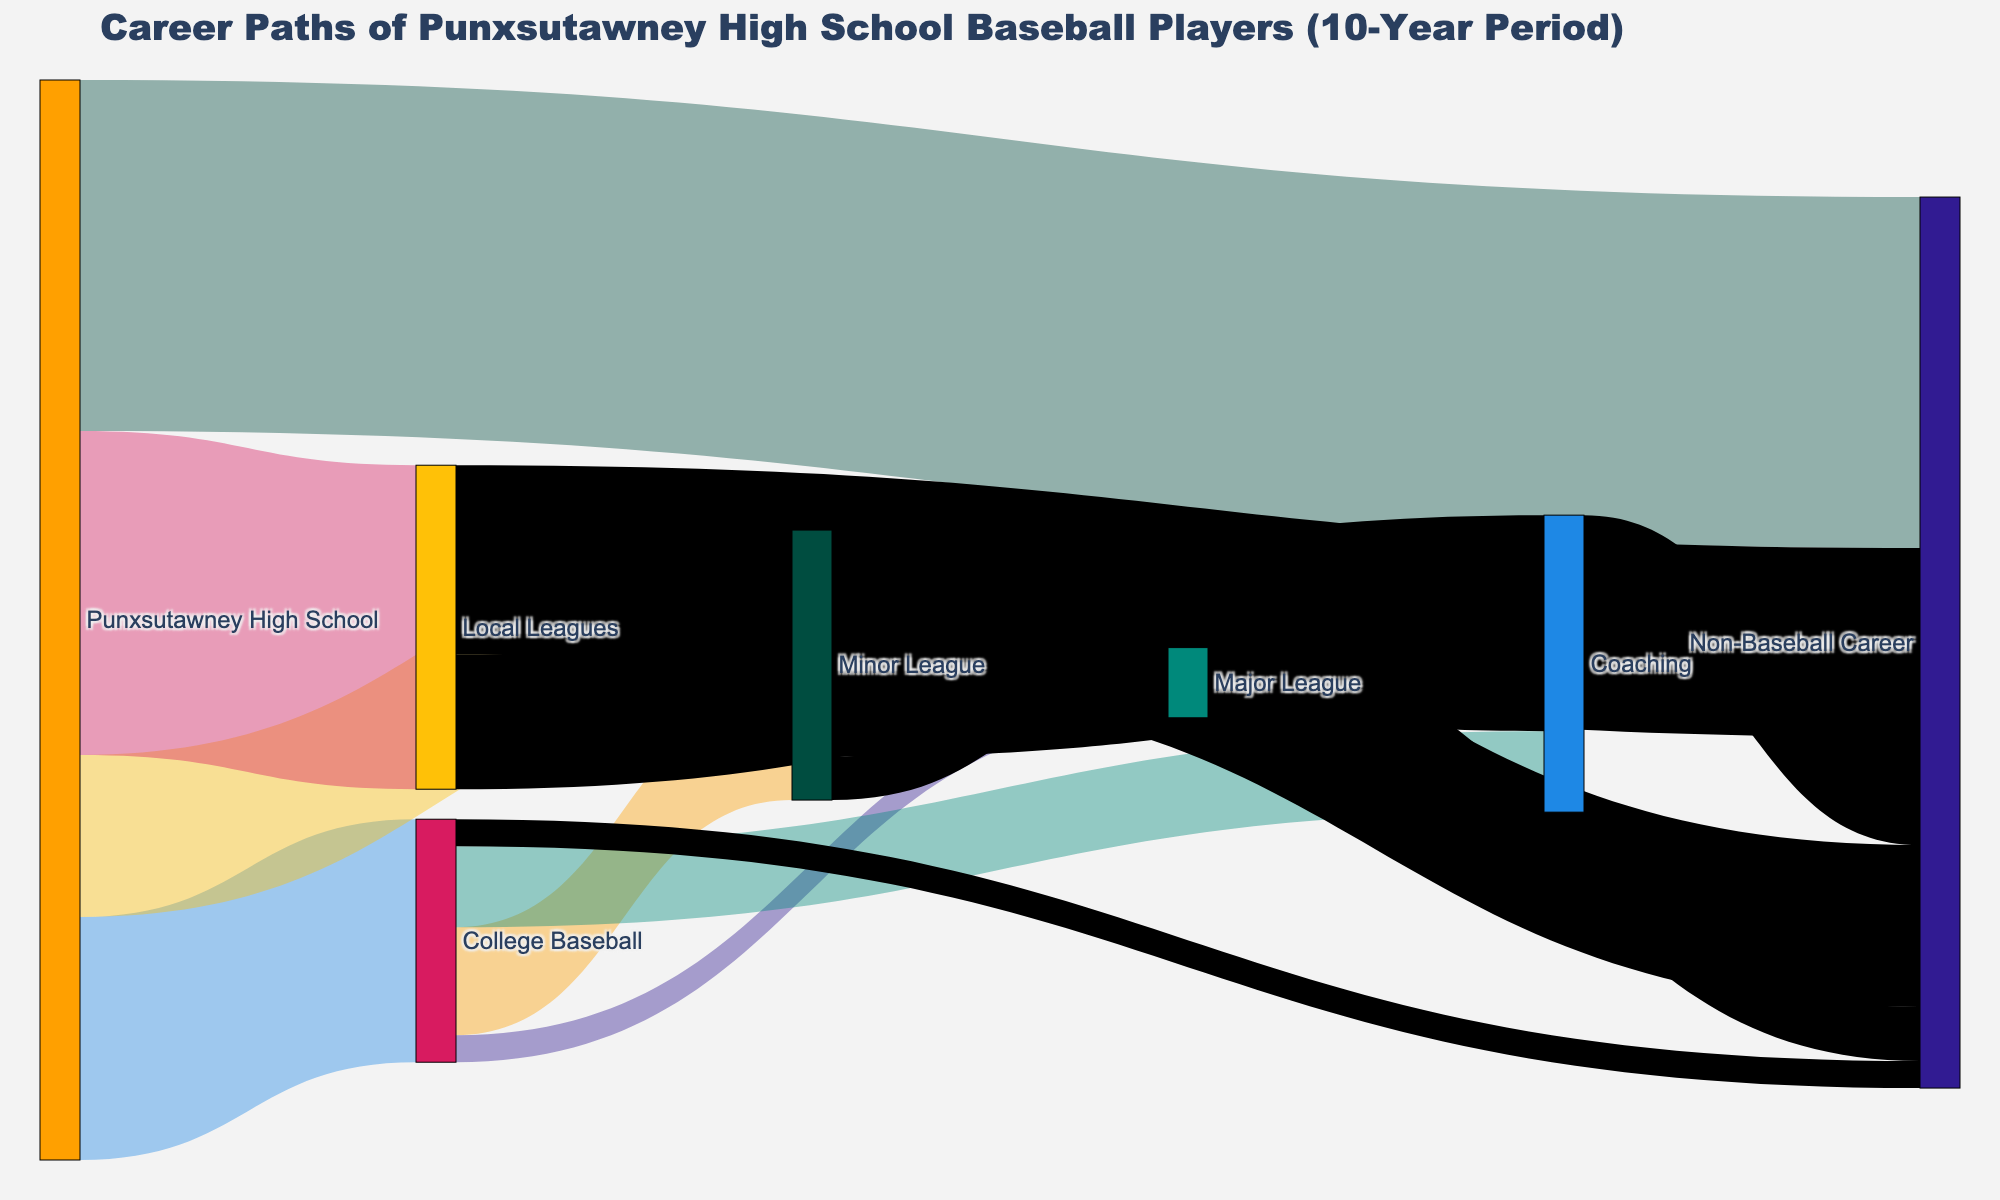What is the title of the figure? The title of the Sankey Diagram is usually located at the top of the figure. By reading this title, one can understand the primary focus of the figure.
Answer: Career Paths of Punxsutawney High School Baseball Players (10-Year Period) How many players went directly from Punxsutawney High School to College Baseball? By looking at the width of the stream and the label between "Punxsutawney High School" and "College Baseball," one can see the number of players.
Answer: 45 What is the total number of players who pursued a career in Coaching? To determine the total number of Coaches, sum the values of streams ending at "Coaching." They come from College Baseball (15), Minor League (12), Local Leagues (25), and Major Leagues (3): 15+12+25+3=55.
Answer: 55 Which career path has the highest number of players starting from Punxsutawney High School? To find this, identify which stream originating from "Punxsutawney High School" is the widest and has the largest value.
Answer: Non-Baseball Career How many players transitioned from College Baseball to a major league career? Look at the width of the stream between "College Baseball" and "Major League" and refer to the label for the exact number.
Answer: 5 What percentage of players from Punxsutawney High School joined Local Leagues? The total number of students from Punxsutawney High School is 200 (sum of all outgoing streams). Calculate the percentage: (60/200) * 100 = 30%.
Answer: 30% Compare the number of players in the Minor League to those in the Major League. Combine the streams leading into Minor League and Major League, respectively. Minor League receives 30 (from High School) + 20 (from College) = 50. Major League receives 5 (from College) + 8 (from Minor League) = 13. There are 50 in Minor League and 13 in Major League.
Answer: 50 (Minor League) vs. 13 (Major League) What is the most common eventual career for players who started in Local Leagues? Identify the largest stream originating from "Local Leagues" by its width and label, which ends at "Non-Baseball Career" with a value of 35.
Answer: Non-Baseball Career How many players moved from Minor League to a Non-Baseball Career? Look for the stream linking "Minor League" to "Non-Baseball Career" and read the value.
Answer: 30 What is the total number of players who eventually pursued a Non-Baseball Career? Sum all streams that end at "Non-Baseball Career": 65 (from High School) + 5 (from College) + 30 (from Minor League) + 35 (from Local Leagues) + 10 (from Major League) + 20 (from Coaching) = 165.
Answer: 165 